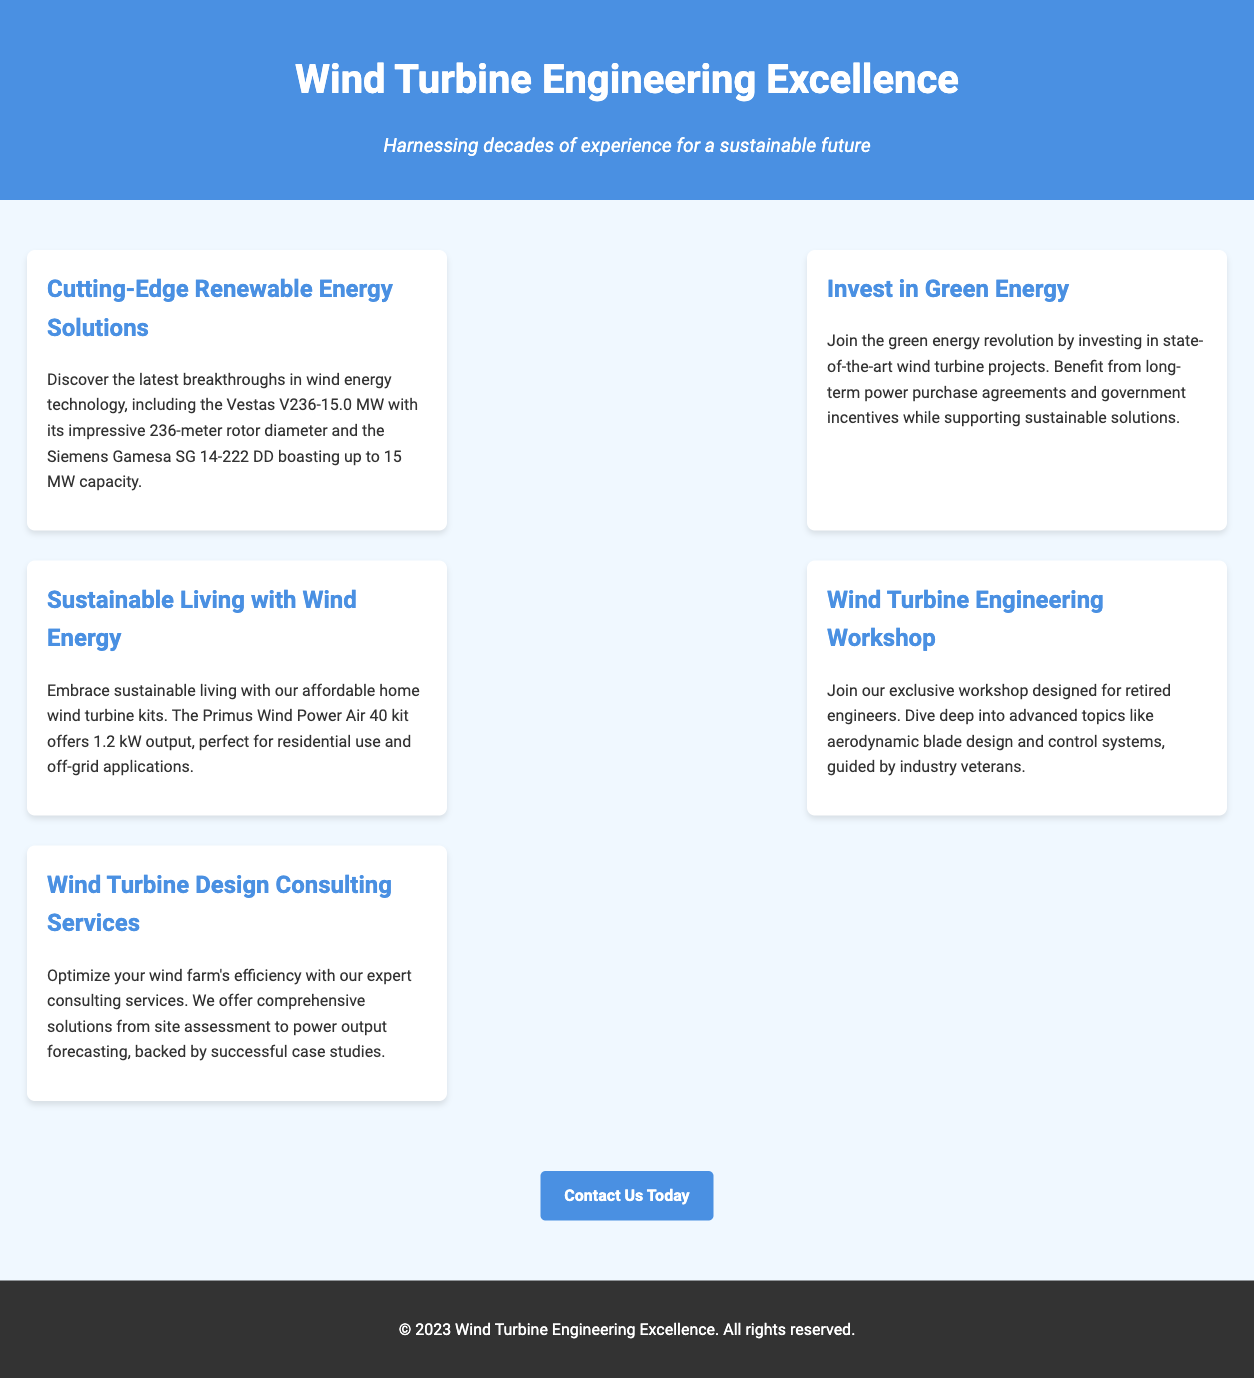What is the rotor diameter of the Vestas turbine? The document provides the rotor diameter as part of the specifications for the Vestas V236-15.0 MW turbine.
Answer: 236 meters What is the output of the Primus Wind Power Air 40 kit? The document includes the output specifications for the home wind turbine kit.
Answer: 1.2 kW What type of project is highlighted in the "Invest in Green Energy" section? This section discusses a specific opportunity for investment, mentioning the type of projects involved.
Answer: Wind turbine projects Who is the target audience for the Wind Turbine Engineering Workshop? The document specifies the intended participants for the workshop, focusing on a particular group.
Answer: Retired engineers What is the capacity of the Siemens Gamesa turbine? The document mentions the capacity of the Siemens Gamesa SG 14-222 DD in its specifications.
Answer: Up to 15 MW What kind of solutions do the consulting services aim to optimize? The consulting services description indicates the focus areas for improving performance.
Answer: Wind farm efficiency What is the main focus of the Cutting-Edge Renewable Energy Solutions section? The document outlines the focus of this section on advancements in technology.
Answer: Latest breakthroughs What is provided alongside the installation guidelines in the home wind turbine kit offer? The document mentions additional information included with the home wind turbine kits.
Answer: Maintenance tips 